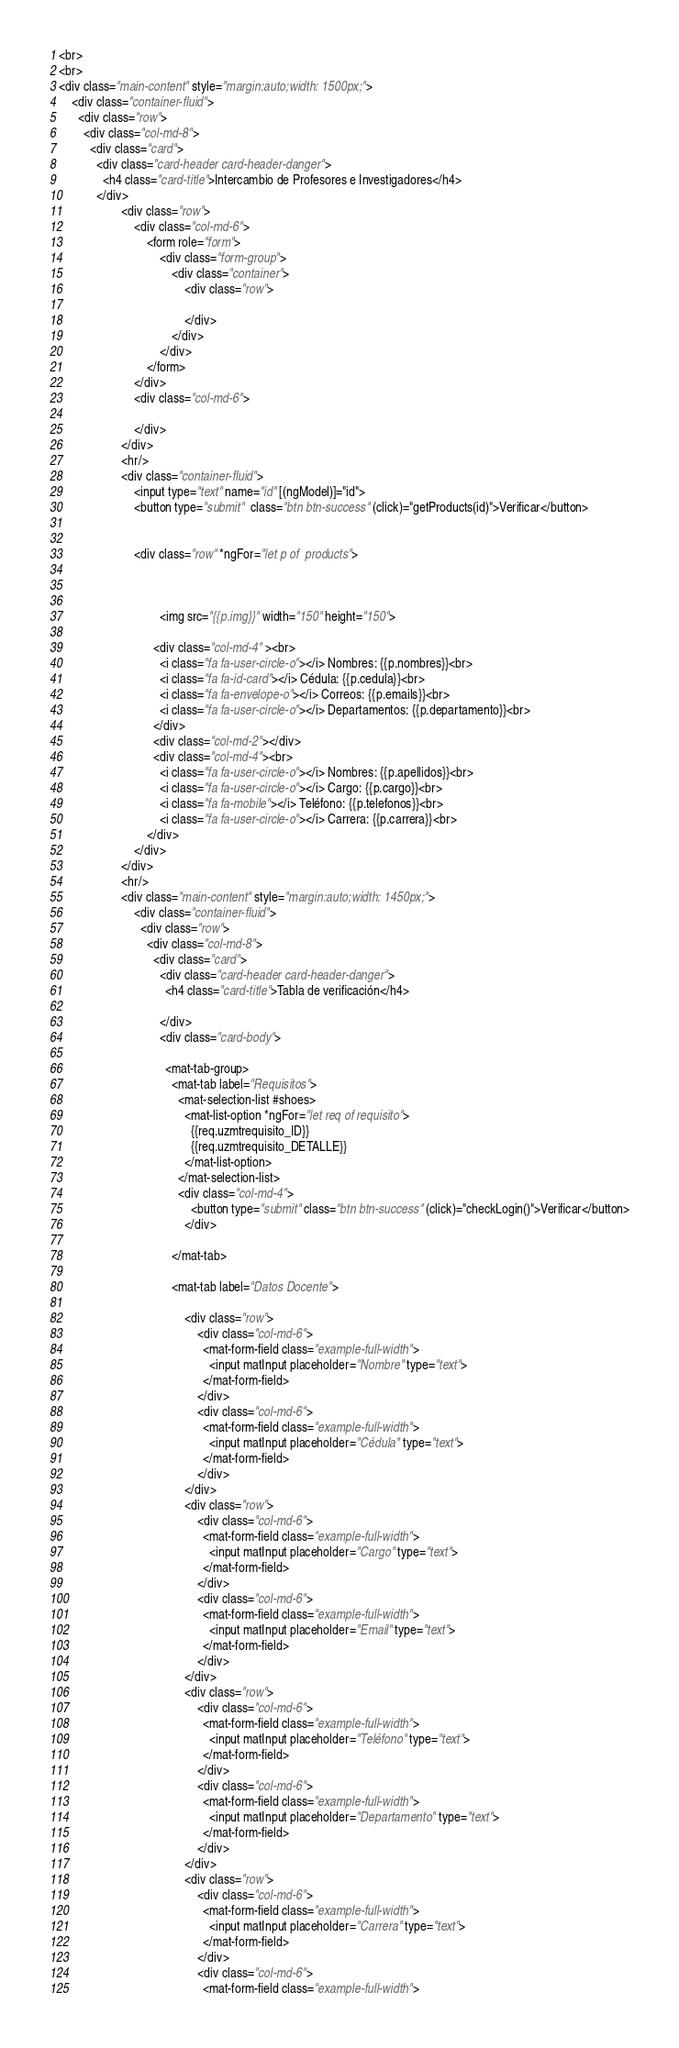Convert code to text. <code><loc_0><loc_0><loc_500><loc_500><_HTML_><br>
<br>
<div class="main-content" style="margin:auto;width: 1500px;">
    <div class="container-fluid">
      <div class="row">
        <div class="col-md-8">
          <div class="card">
            <div class="card-header card-header-danger">
              <h4 class="card-title">Intercambio de Profesores e Investigadores</h4>
            </div>
                    <div class="row">
                        <div class="col-md-6">
                            <form role="form">
                                <div class="form-group">
                                    <div class="container">
                                        <div class="row">
                                            
                                        </div>
                                    </div>
                                </div>
                            </form>
                        </div>
                        <div class="col-md-6">
                            
                        </div>
                    </div>
                    <hr/>
                    <div class="container-fluid">
                        <input type="text" name="id" [(ngModel)]="id">
                        <button type="submit"  class="btn btn-success" (click)="getProducts(id)">Verificar</button>
                        
                        
                        <div class="row" *ngFor="let p of  products">
                        
                          

                                <img src="{{p.img}}" width="150" height="150">
                           
                              <div class="col-md-4" ><br>
                                <i class="fa fa-user-circle-o"></i> Nombres: {{p.nombres}}<br>
                                <i class="fa fa-id-card"></i> Cédula: {{p.cedula}}<br>
                                <i class="fa fa-envelope-o"></i> Correos: {{p.emails}}<br>
                                <i class="fa fa-user-circle-o"></i> Departamentos: {{p.departamento}}<br>
                              </div>
                              <div class="col-md-2"></div>
                              <div class="col-md-4"><br>
                                <i class="fa fa-user-circle-o"></i> Nombres: {{p.apellidos}}<br>
                                <i class="fa fa-user-circle-o"></i> Cargo: {{p.cargo}}<br>
                                <i class="fa fa-mobile"></i> Teléfono: {{p.telefonos}}<br>
                                <i class="fa fa-user-circle-o"></i> Carrera: {{p.carrera}}<br>
                            </div>
                        </div>
                    </div>
                    <hr/>
                    <div class="main-content" style="margin:auto;width: 1450px;">
                        <div class="container-fluid">
                          <div class="row">
                            <div class="col-md-8">
                              <div class="card">
                                <div class="card-header card-header-danger">
                                  <h4 class="card-title">Tabla de verificación</h4>
                                  
                                </div>
                                <div class="card-body">
                      
                                  <mat-tab-group>
                                    <mat-tab label="Requisitos">
                                      <mat-selection-list #shoes>
                                        <mat-list-option *ngFor="let req of requisito">
                                          {{req.uzmtrequisito_ID}}
                                          {{req.uzmtrequisito_DETALLE}}
                                        </mat-list-option>
                                      </mat-selection-list>
                                      <div class="col-md-4">
                                          <button type="submit" class="btn btn-success" (click)="checkLogin()">Verificar</button>
                                        </div>
                      
                                    </mat-tab>
                      
                                    <mat-tab label="Datos Docente">

                                        <div class="row">
                                            <div class="col-md-6">
                                              <mat-form-field class="example-full-width">
                                                <input matInput placeholder="Nombre" type="text">
                                              </mat-form-field>
                                            </div>
                                            <div class="col-md-6">
                                              <mat-form-field class="example-full-width">
                                                <input matInput placeholder="Cédula" type="text">
                                              </mat-form-field>
                                            </div>
                                        </div>
                                        <div class="row">
                                            <div class="col-md-6">
                                              <mat-form-field class="example-full-width">
                                                <input matInput placeholder="Cargo" type="text">
                                              </mat-form-field>
                                            </div>
                                            <div class="col-md-6">
                                              <mat-form-field class="example-full-width">
                                                <input matInput placeholder="Email" type="text">
                                              </mat-form-field>
                                            </div>
                                        </div>
                                        <div class="row">
                                            <div class="col-md-6">
                                              <mat-form-field class="example-full-width">
                                                <input matInput placeholder="Teléfono" type="text">
                                              </mat-form-field>
                                            </div>
                                            <div class="col-md-6">
                                              <mat-form-field class="example-full-width">
                                                <input matInput placeholder="Departamento" type="text">
                                              </mat-form-field>
                                            </div>
                                        </div>
                                        <div class="row">
                                            <div class="col-md-6">
                                              <mat-form-field class="example-full-width">
                                                <input matInput placeholder="Carrera" type="text">
                                              </mat-form-field>
                                            </div>
                                            <div class="col-md-6">
                                              <mat-form-field class="example-full-width"></code> 